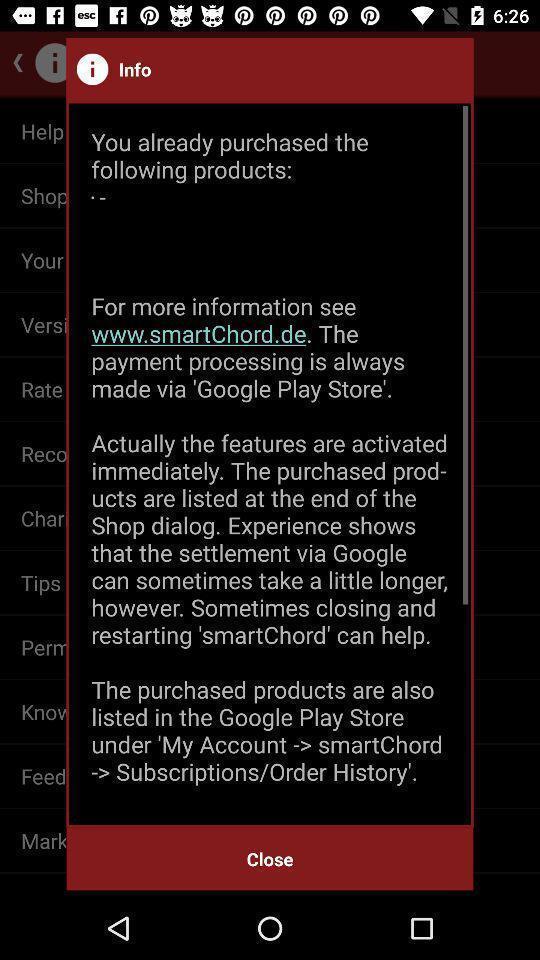Summarize the main components in this picture. Popup of information in a music learning app. 